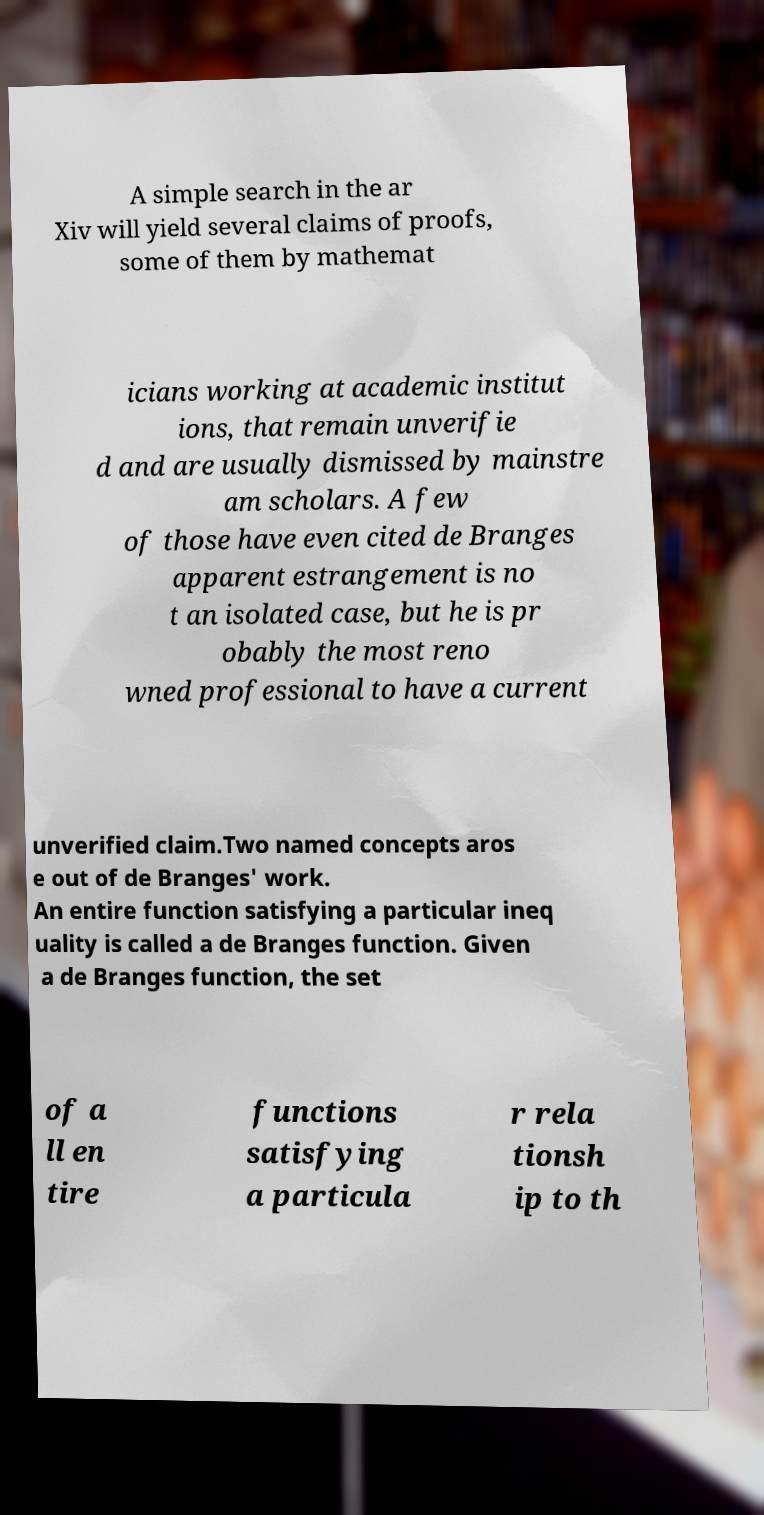Please identify and transcribe the text found in this image. A simple search in the ar Xiv will yield several claims of proofs, some of them by mathemat icians working at academic institut ions, that remain unverifie d and are usually dismissed by mainstre am scholars. A few of those have even cited de Branges apparent estrangement is no t an isolated case, but he is pr obably the most reno wned professional to have a current unverified claim.Two named concepts aros e out of de Branges' work. An entire function satisfying a particular ineq uality is called a de Branges function. Given a de Branges function, the set of a ll en tire functions satisfying a particula r rela tionsh ip to th 